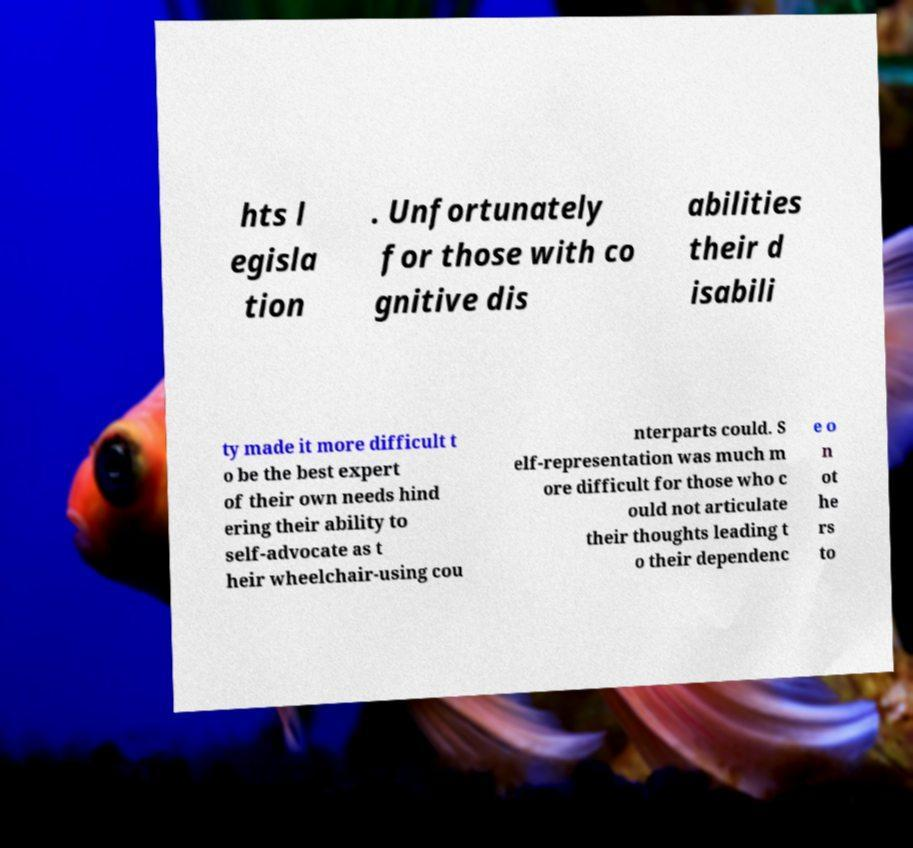Can you accurately transcribe the text from the provided image for me? hts l egisla tion . Unfortunately for those with co gnitive dis abilities their d isabili ty made it more difficult t o be the best expert of their own needs hind ering their ability to self-advocate as t heir wheelchair-using cou nterparts could. S elf-representation was much m ore difficult for those who c ould not articulate their thoughts leading t o their dependenc e o n ot he rs to 